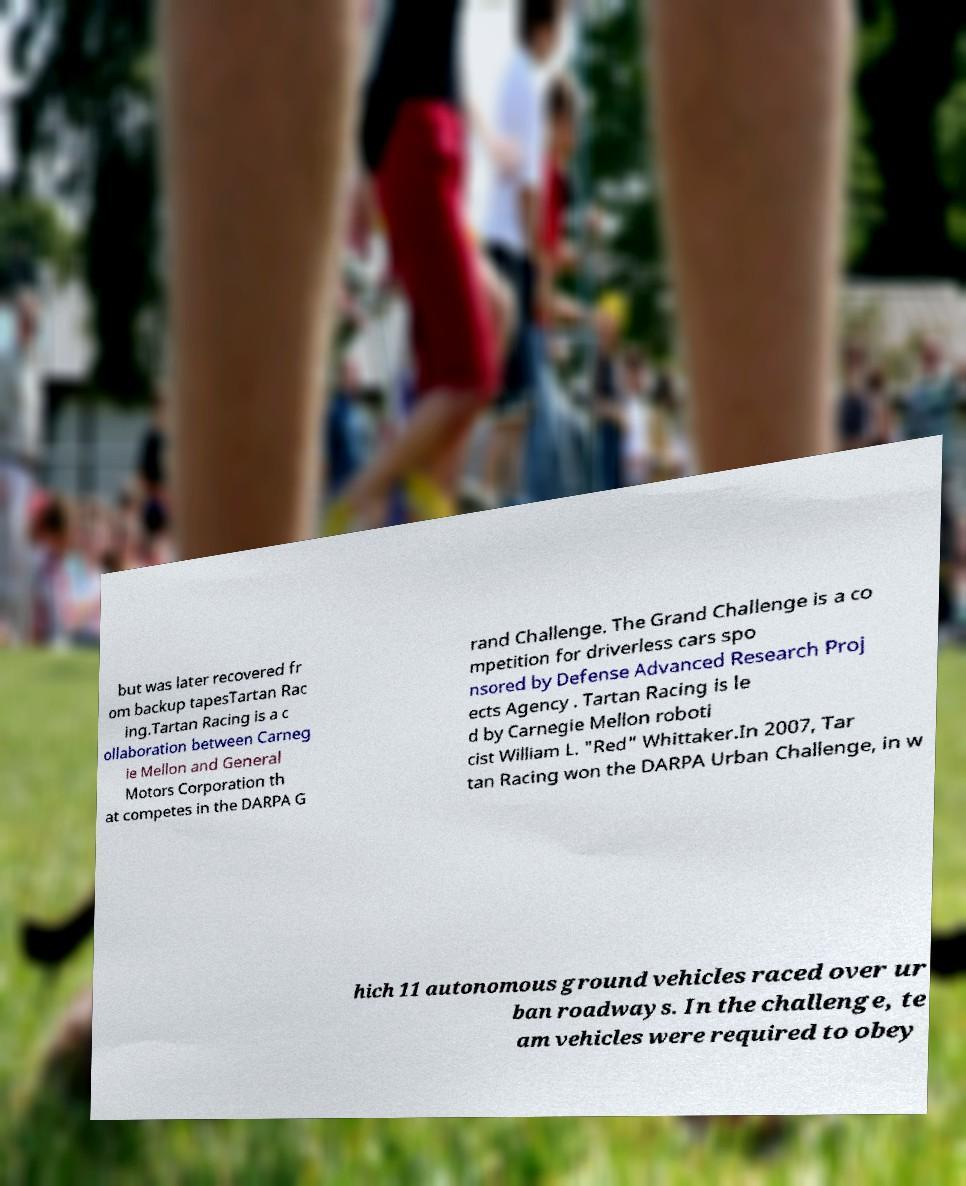Can you read and provide the text displayed in the image?This photo seems to have some interesting text. Can you extract and type it out for me? but was later recovered fr om backup tapesTartan Rac ing.Tartan Racing is a c ollaboration between Carneg ie Mellon and General Motors Corporation th at competes in the DARPA G rand Challenge. The Grand Challenge is a co mpetition for driverless cars spo nsored by Defense Advanced Research Proj ects Agency . Tartan Racing is le d by Carnegie Mellon roboti cist William L. "Red" Whittaker.In 2007, Tar tan Racing won the DARPA Urban Challenge, in w hich 11 autonomous ground vehicles raced over ur ban roadways. In the challenge, te am vehicles were required to obey 